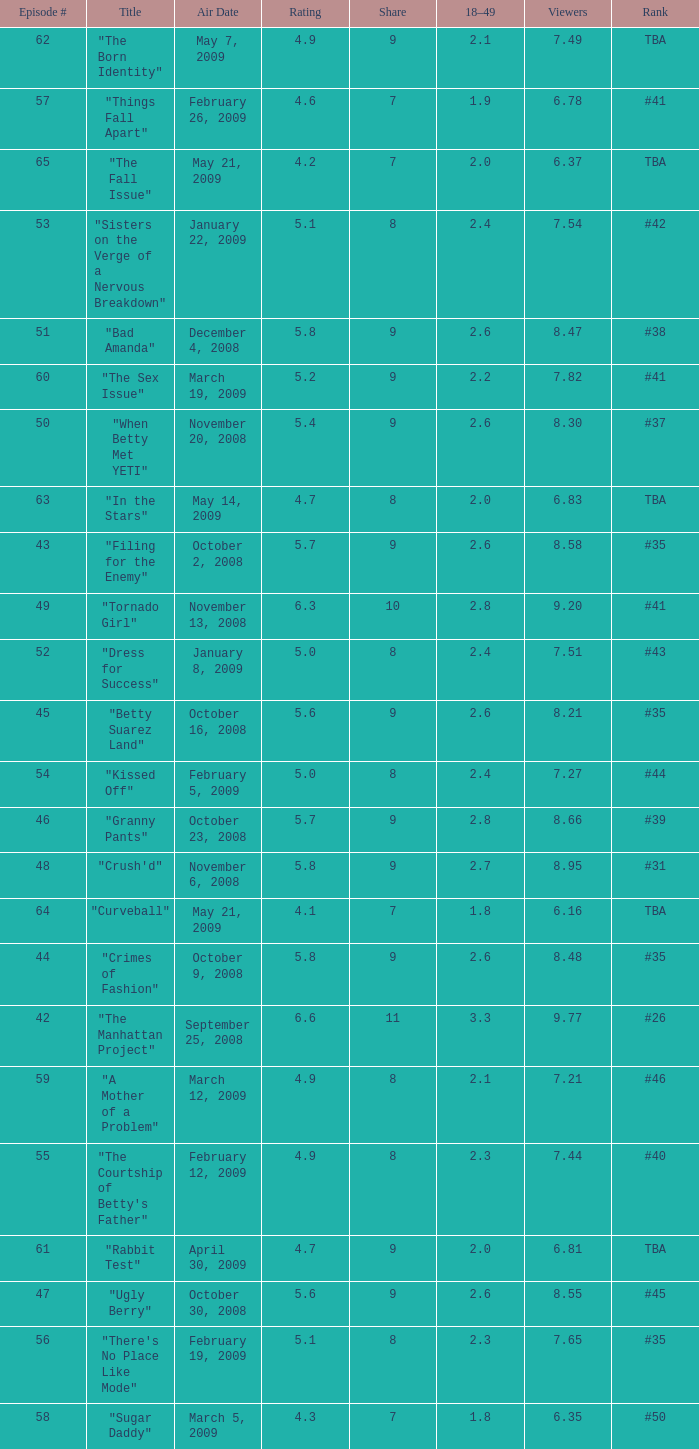What is the average Episode # with a share of 9, and #35 is rank and less than 8.21 viewers? None. 